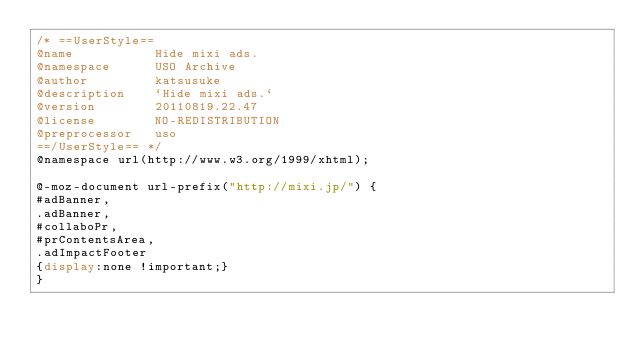Convert code to text. <code><loc_0><loc_0><loc_500><loc_500><_CSS_>/* ==UserStyle==
@name           Hide mixi ads.
@namespace      USO Archive
@author         katsusuke
@description    `Hide mixi ads.`
@version        20110819.22.47
@license        NO-REDISTRIBUTION
@preprocessor   uso
==/UserStyle== */
@namespace url(http://www.w3.org/1999/xhtml);

@-moz-document url-prefix("http://mixi.jp/") {
#adBanner,
.adBanner,
#collaboPr,
#prContentsArea,
.adImpactFooter
{display:none !important;}
}
</code> 